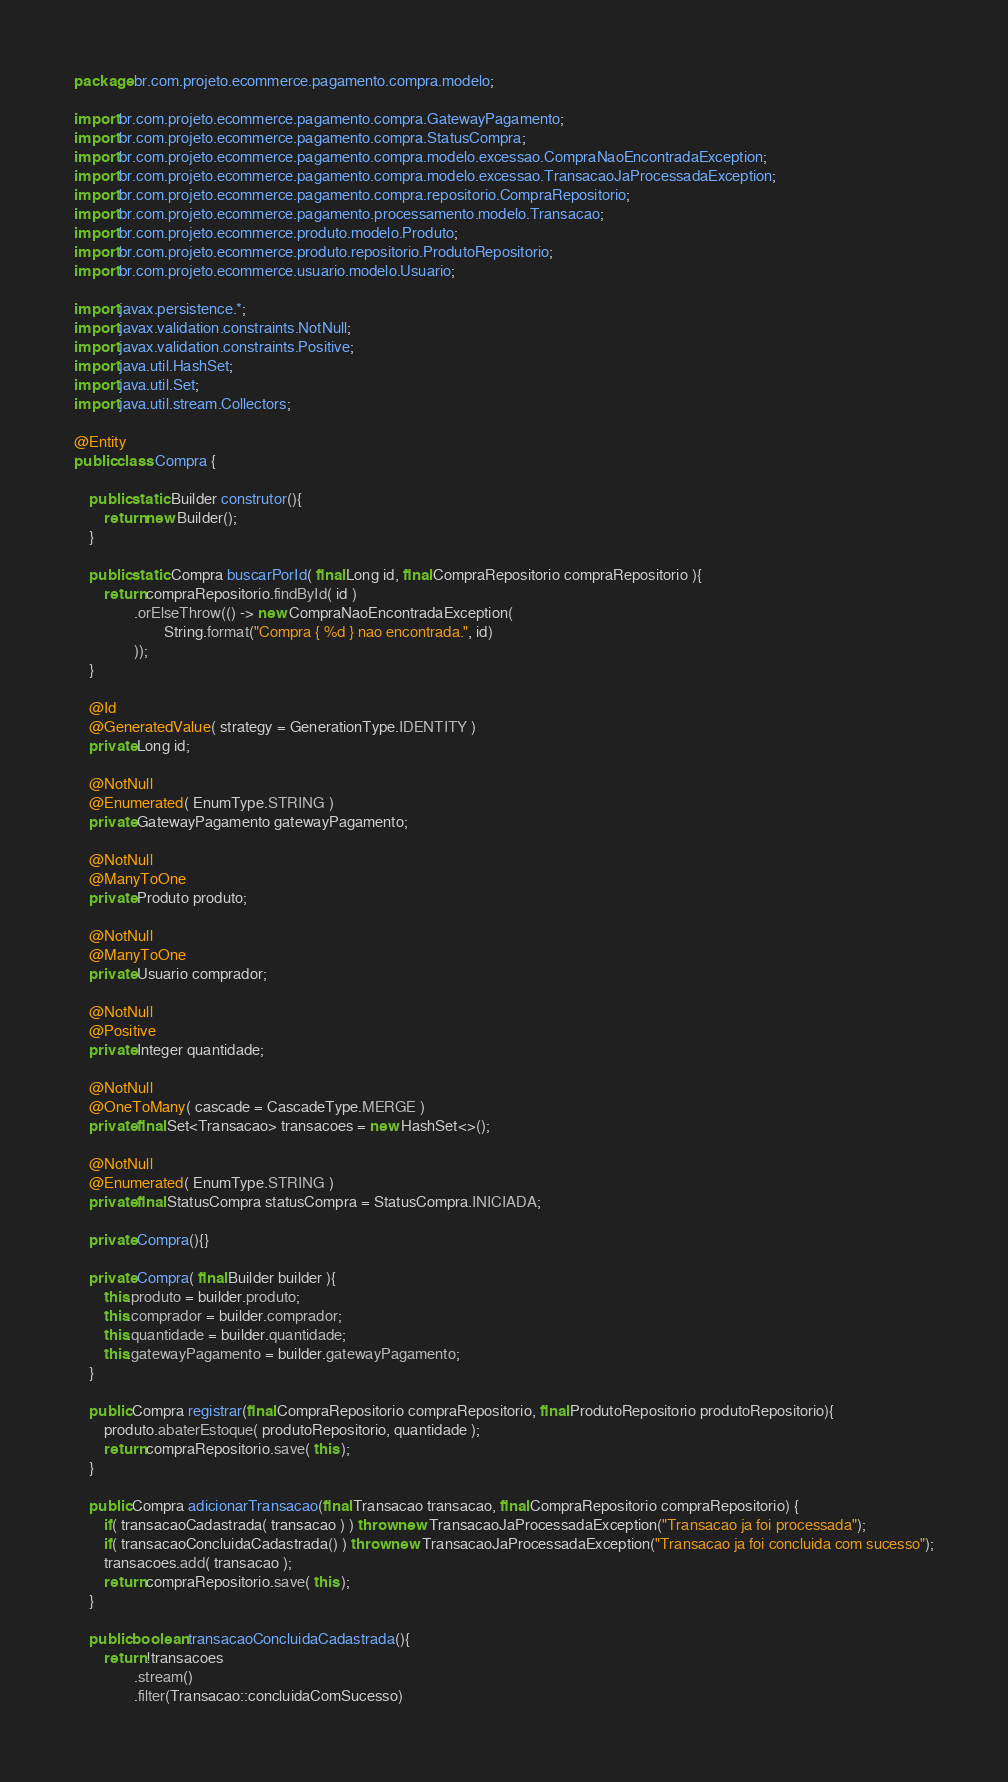<code> <loc_0><loc_0><loc_500><loc_500><_Java_>package br.com.projeto.ecommerce.pagamento.compra.modelo;

import br.com.projeto.ecommerce.pagamento.compra.GatewayPagamento;
import br.com.projeto.ecommerce.pagamento.compra.StatusCompra;
import br.com.projeto.ecommerce.pagamento.compra.modelo.excessao.CompraNaoEncontradaException;
import br.com.projeto.ecommerce.pagamento.compra.modelo.excessao.TransacaoJaProcessadaException;
import br.com.projeto.ecommerce.pagamento.compra.repositorio.CompraRepositorio;
import br.com.projeto.ecommerce.pagamento.processamento.modelo.Transacao;
import br.com.projeto.ecommerce.produto.modelo.Produto;
import br.com.projeto.ecommerce.produto.repositorio.ProdutoRepositorio;
import br.com.projeto.ecommerce.usuario.modelo.Usuario;

import javax.persistence.*;
import javax.validation.constraints.NotNull;
import javax.validation.constraints.Positive;
import java.util.HashSet;
import java.util.Set;
import java.util.stream.Collectors;

@Entity
public class Compra {

    public static Builder construtor(){
        return new Builder();
    }

    public static Compra buscarPorId( final Long id, final CompraRepositorio compraRepositorio ){
        return compraRepositorio.findById( id )
                .orElseThrow(() -> new CompraNaoEncontradaException(
                        String.format("Compra { %d } nao encontrada.", id)
                ));
    }

    @Id
    @GeneratedValue( strategy = GenerationType.IDENTITY )
    private Long id;

    @NotNull
    @Enumerated( EnumType.STRING )
    private GatewayPagamento gatewayPagamento;

    @NotNull
    @ManyToOne
    private Produto produto;

    @NotNull
    @ManyToOne
    private Usuario comprador;

    @NotNull
    @Positive
    private Integer quantidade;

    @NotNull
    @OneToMany( cascade = CascadeType.MERGE )
    private final Set<Transacao> transacoes = new HashSet<>();

    @NotNull
    @Enumerated( EnumType.STRING )
    private final StatusCompra statusCompra = StatusCompra.INICIADA;

    private Compra(){}

    private Compra( final Builder builder ){
        this.produto = builder.produto;
        this.comprador = builder.comprador;
        this.quantidade = builder.quantidade;
        this.gatewayPagamento = builder.gatewayPagamento;
    }

    public Compra registrar(final CompraRepositorio compraRepositorio, final ProdutoRepositorio produtoRepositorio){
        produto.abaterEstoque( produtoRepositorio, quantidade );
        return compraRepositorio.save( this );
    }

    public Compra adicionarTransacao(final Transacao transacao, final CompraRepositorio compraRepositorio) {
        if( transacaoCadastrada( transacao ) ) throw new TransacaoJaProcessadaException("Transacao ja foi processada");
        if( transacaoConcluidaCadastrada() ) throw new TransacaoJaProcessadaException("Transacao ja foi concluida com sucesso");
        transacoes.add( transacao );
        return compraRepositorio.save( this );
    }

    public boolean transacaoConcluidaCadastrada(){
        return !transacoes
                .stream()
                .filter(Transacao::concluidaComSucesso)</code> 